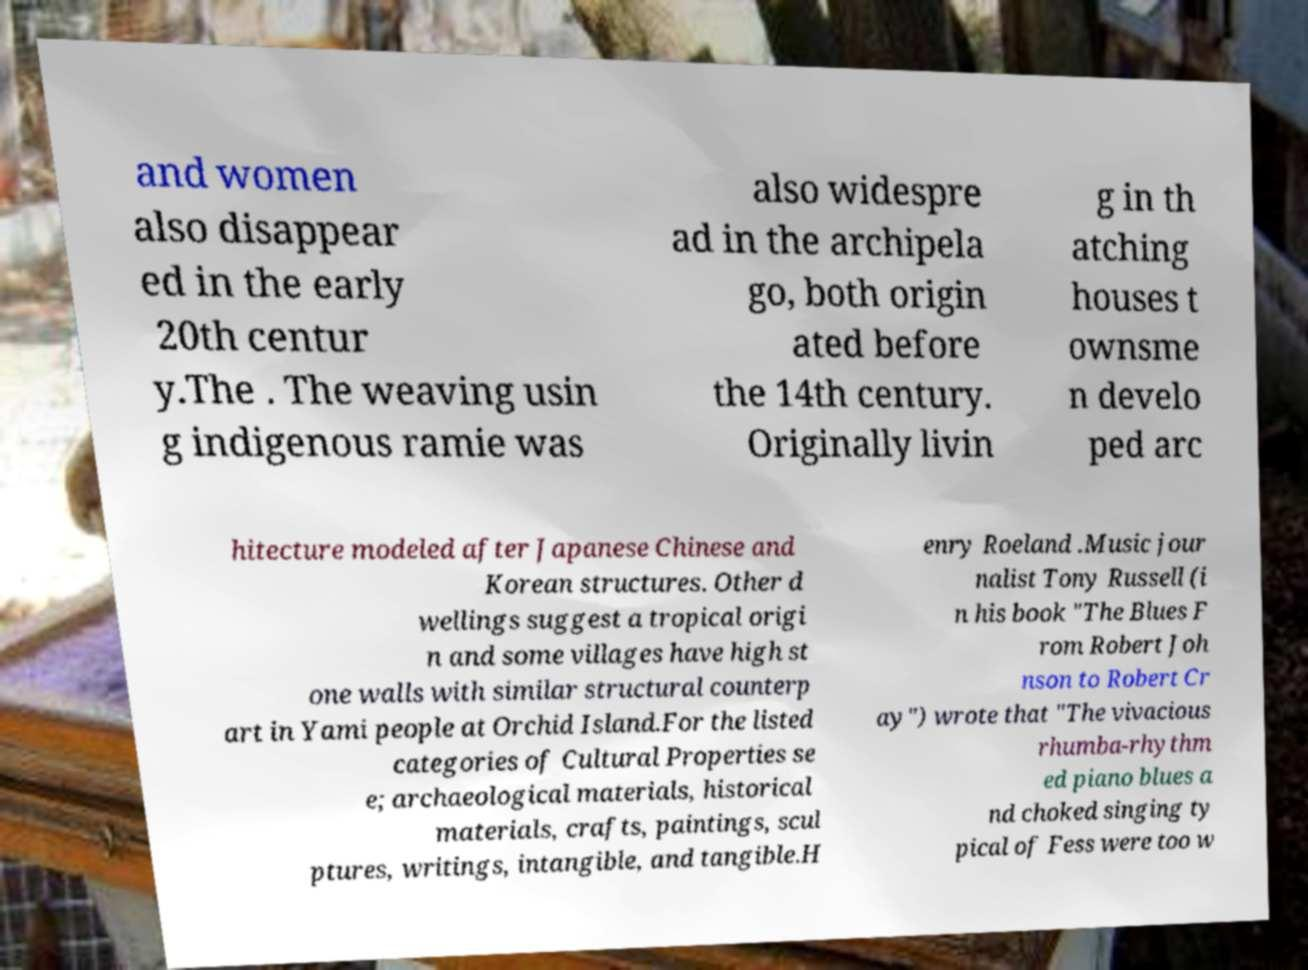Can you read and provide the text displayed in the image?This photo seems to have some interesting text. Can you extract and type it out for me? and women also disappear ed in the early 20th centur y.The . The weaving usin g indigenous ramie was also widespre ad in the archipela go, both origin ated before the 14th century. Originally livin g in th atching houses t ownsme n develo ped arc hitecture modeled after Japanese Chinese and Korean structures. Other d wellings suggest a tropical origi n and some villages have high st one walls with similar structural counterp art in Yami people at Orchid Island.For the listed categories of Cultural Properties se e; archaeological materials, historical materials, crafts, paintings, scul ptures, writings, intangible, and tangible.H enry Roeland .Music jour nalist Tony Russell (i n his book "The Blues F rom Robert Joh nson to Robert Cr ay") wrote that "The vivacious rhumba-rhythm ed piano blues a nd choked singing ty pical of Fess were too w 